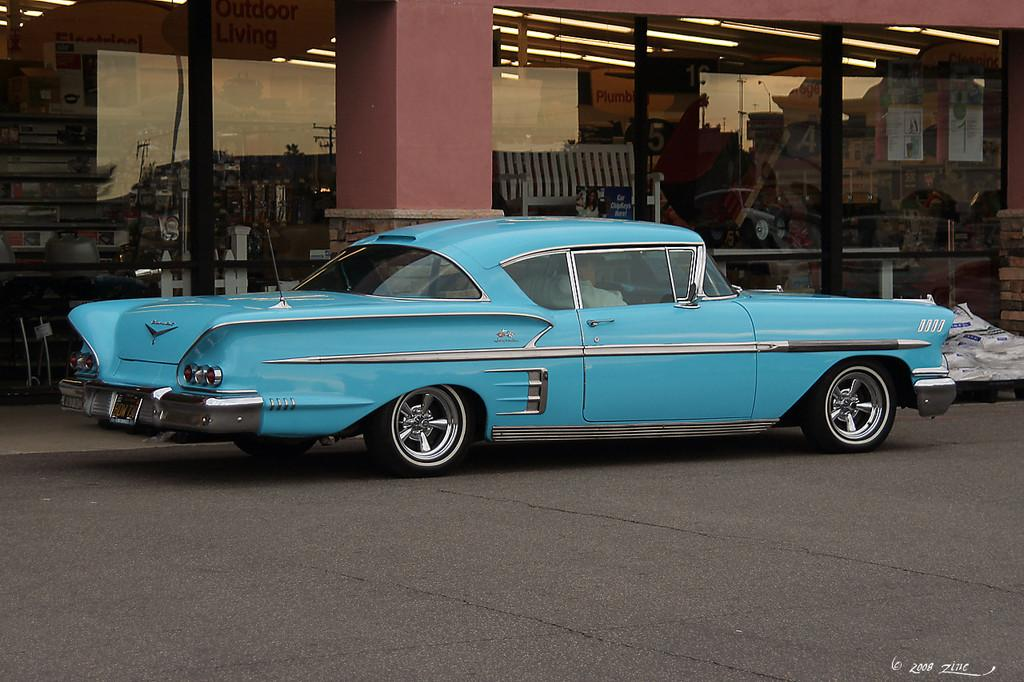What type of vehicle is on the road in the image? There is a car on the road in the image. What type of seating is present in the image? There is a bench in the image. What can be seen illuminating the scene in the image? There are lights in the image. What type of objects are present in the image? There are objects in the image, such as the car, bench, and lights. What can be seen reflecting in the glass in the image? There is a glass with the reflection of buildings in the image. What type of vegetation is visible in the image? Trees are visible in the image. What type of vertical structures are present in the image? There are poles in the image. What part of the natural environment is visible in the image? The sky is visible in the image. How many points does the servant have in the image? There is no servant present in the image, so it is not possible to determine how many points they might have. 